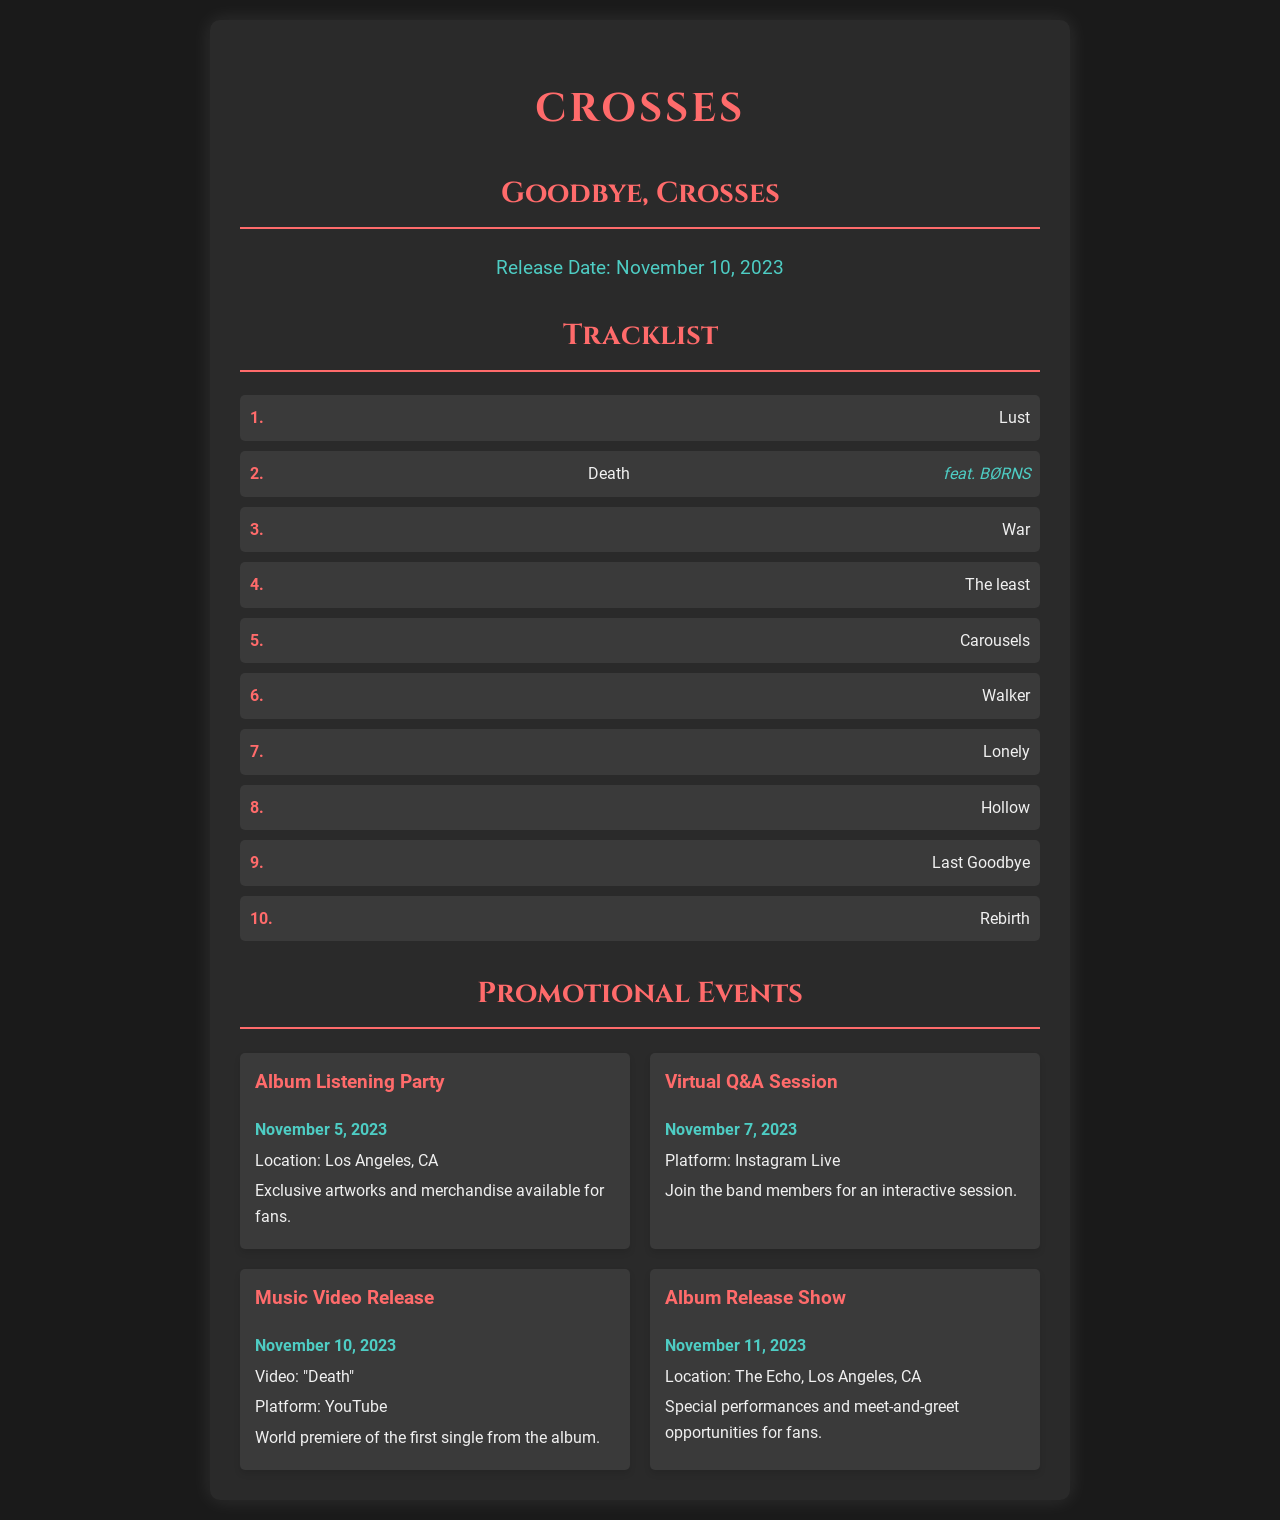What is the album title? The album title is clearly indicated in the document, stated as "Goodbye, Crosses."
Answer: Goodbye, Crosses When is the album release date? The release date is mentioned under the release date section in the document as November 10, 2023.
Answer: November 10, 2023 How many tracks are listed in the tracklist? The tracklist section mentions a total of ten tracks as enumerated in the list.
Answer: 10 Which track features BØRNS? The track that features BØRNS is specified as "Death" in the tracklist.
Answer: Death What is the date of the Album Listening Party? The date of the Album Listening Party is provided in the events section as November 5, 2023.
Answer: November 5, 2023 Where will the Album Release Show be held? The location for the Album Release Show is stated as "The Echo, Los Angeles, CA" in the events section.
Answer: The Echo, Los Angeles, CA What is the title of the music video being released? The title of the music video being released is directly mentioned in the promotional events as "Death."
Answer: Death What is the platform for the Virtual Q&A Session? The platform for the Virtual Q&A Session is specified as Instagram Live in the events section.
Answer: Instagram Live What special feature is mentioned for the Album Release Show? A special feature for the Album Release Show is mentioned as “meet-and-greet opportunities for fans.”
Answer: meet-and-greet opportunities for fans 